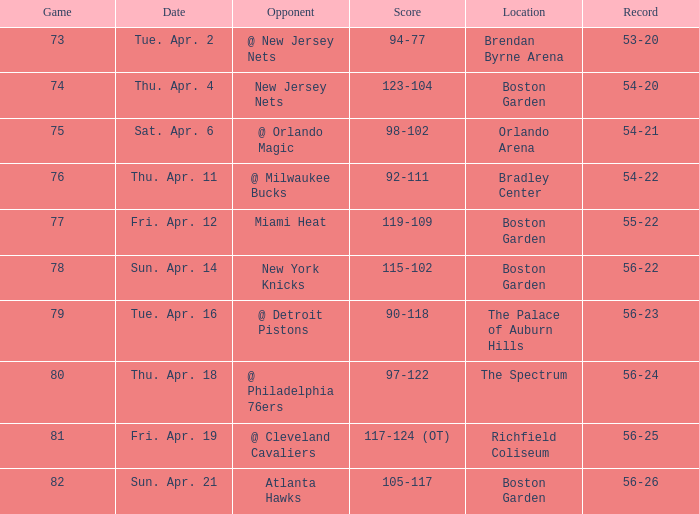Which Score has a Location of richfield coliseum? 117-124 (OT). 